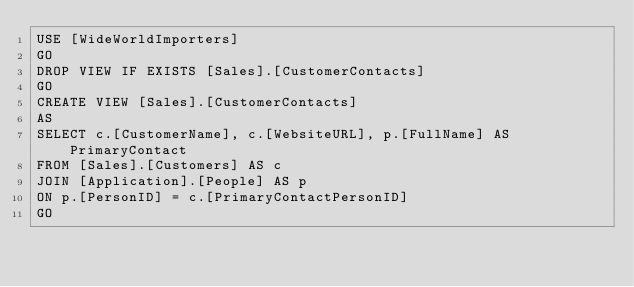<code> <loc_0><loc_0><loc_500><loc_500><_SQL_>USE [WideWorldImporters]
GO
DROP VIEW IF EXISTS [Sales].[CustomerContacts]
GO
CREATE VIEW [Sales].[CustomerContacts]
AS
SELECT c.[CustomerName], c.[WebsiteURL], p.[FullName] AS PrimaryContact
FROM [Sales].[Customers] AS c
JOIN [Application].[People] AS p
ON p.[PersonID] = c.[PrimaryContactPersonID]
GO
</code> 